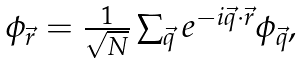Convert formula to latex. <formula><loc_0><loc_0><loc_500><loc_500>\begin{array} { c c c } \phi _ { \vec { r } } = \frac { 1 } { \sqrt { N } } \sum _ { \vec { q } } e ^ { - i \vec { q } \cdot \vec { r } } \phi _ { \vec { q } } , \end{array}</formula> 